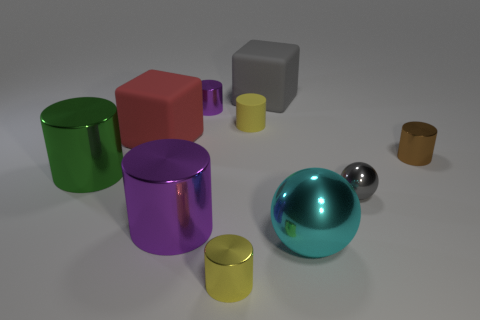Subtract 1 cylinders. How many cylinders are left? 5 Subtract all green shiny cylinders. How many cylinders are left? 5 Subtract all brown cylinders. How many cylinders are left? 5 Subtract all cyan cylinders. Subtract all green blocks. How many cylinders are left? 6 Subtract all spheres. How many objects are left? 8 Subtract 1 cyan spheres. How many objects are left? 9 Subtract all gray metal spheres. Subtract all large cubes. How many objects are left? 7 Add 3 matte blocks. How many matte blocks are left? 5 Add 3 blue rubber spheres. How many blue rubber spheres exist? 3 